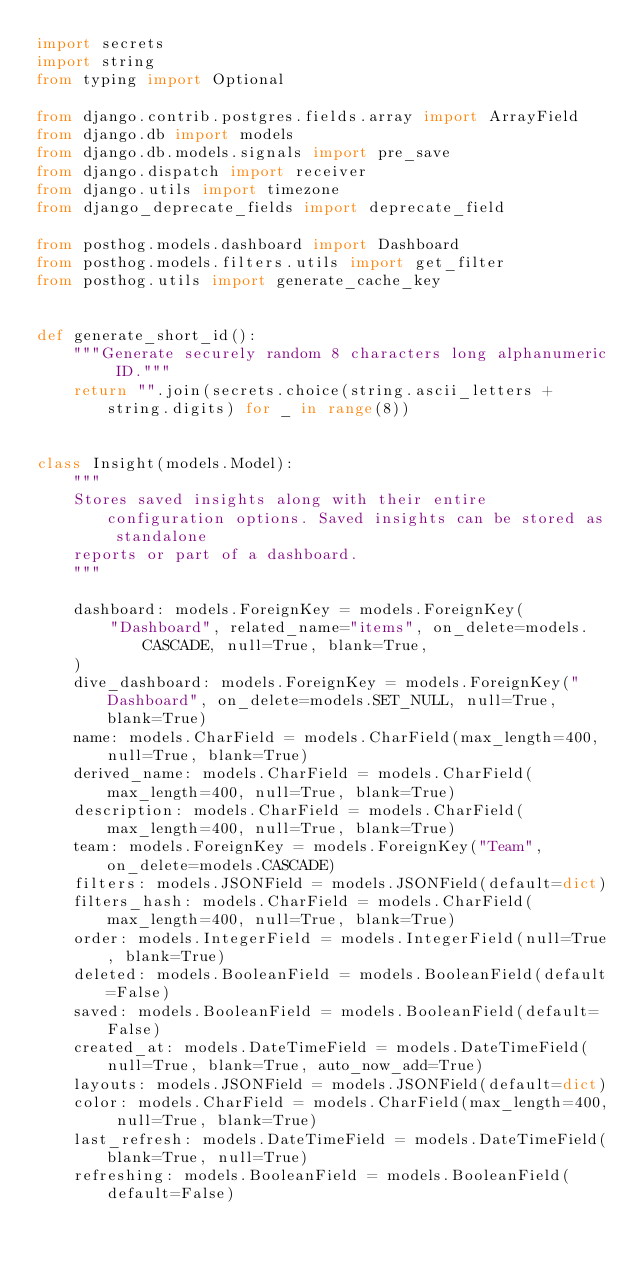<code> <loc_0><loc_0><loc_500><loc_500><_Python_>import secrets
import string
from typing import Optional

from django.contrib.postgres.fields.array import ArrayField
from django.db import models
from django.db.models.signals import pre_save
from django.dispatch import receiver
from django.utils import timezone
from django_deprecate_fields import deprecate_field

from posthog.models.dashboard import Dashboard
from posthog.models.filters.utils import get_filter
from posthog.utils import generate_cache_key


def generate_short_id():
    """Generate securely random 8 characters long alphanumeric ID."""
    return "".join(secrets.choice(string.ascii_letters + string.digits) for _ in range(8))


class Insight(models.Model):
    """
    Stores saved insights along with their entire configuration options. Saved insights can be stored as standalone
    reports or part of a dashboard.
    """

    dashboard: models.ForeignKey = models.ForeignKey(
        "Dashboard", related_name="items", on_delete=models.CASCADE, null=True, blank=True,
    )
    dive_dashboard: models.ForeignKey = models.ForeignKey("Dashboard", on_delete=models.SET_NULL, null=True, blank=True)
    name: models.CharField = models.CharField(max_length=400, null=True, blank=True)
    derived_name: models.CharField = models.CharField(max_length=400, null=True, blank=True)
    description: models.CharField = models.CharField(max_length=400, null=True, blank=True)
    team: models.ForeignKey = models.ForeignKey("Team", on_delete=models.CASCADE)
    filters: models.JSONField = models.JSONField(default=dict)
    filters_hash: models.CharField = models.CharField(max_length=400, null=True, blank=True)
    order: models.IntegerField = models.IntegerField(null=True, blank=True)
    deleted: models.BooleanField = models.BooleanField(default=False)
    saved: models.BooleanField = models.BooleanField(default=False)
    created_at: models.DateTimeField = models.DateTimeField(null=True, blank=True, auto_now_add=True)
    layouts: models.JSONField = models.JSONField(default=dict)
    color: models.CharField = models.CharField(max_length=400, null=True, blank=True)
    last_refresh: models.DateTimeField = models.DateTimeField(blank=True, null=True)
    refreshing: models.BooleanField = models.BooleanField(default=False)</code> 